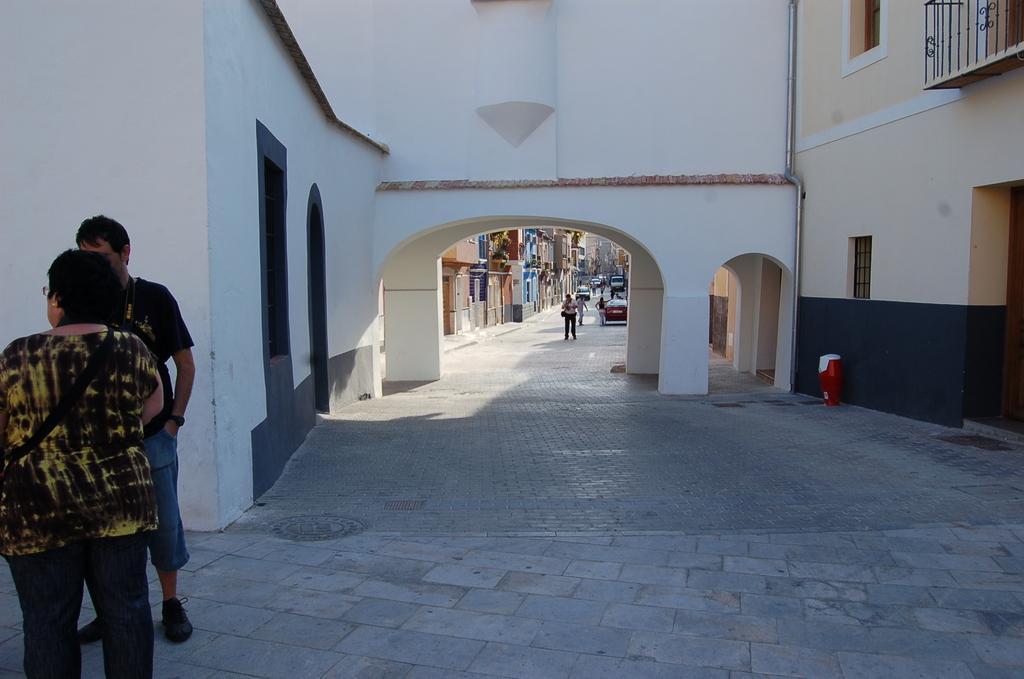In one or two sentences, can you explain what this image depicts? In the image we can see there are people standing on the ground and there are cars parked on the road. Behind there are buildings. 